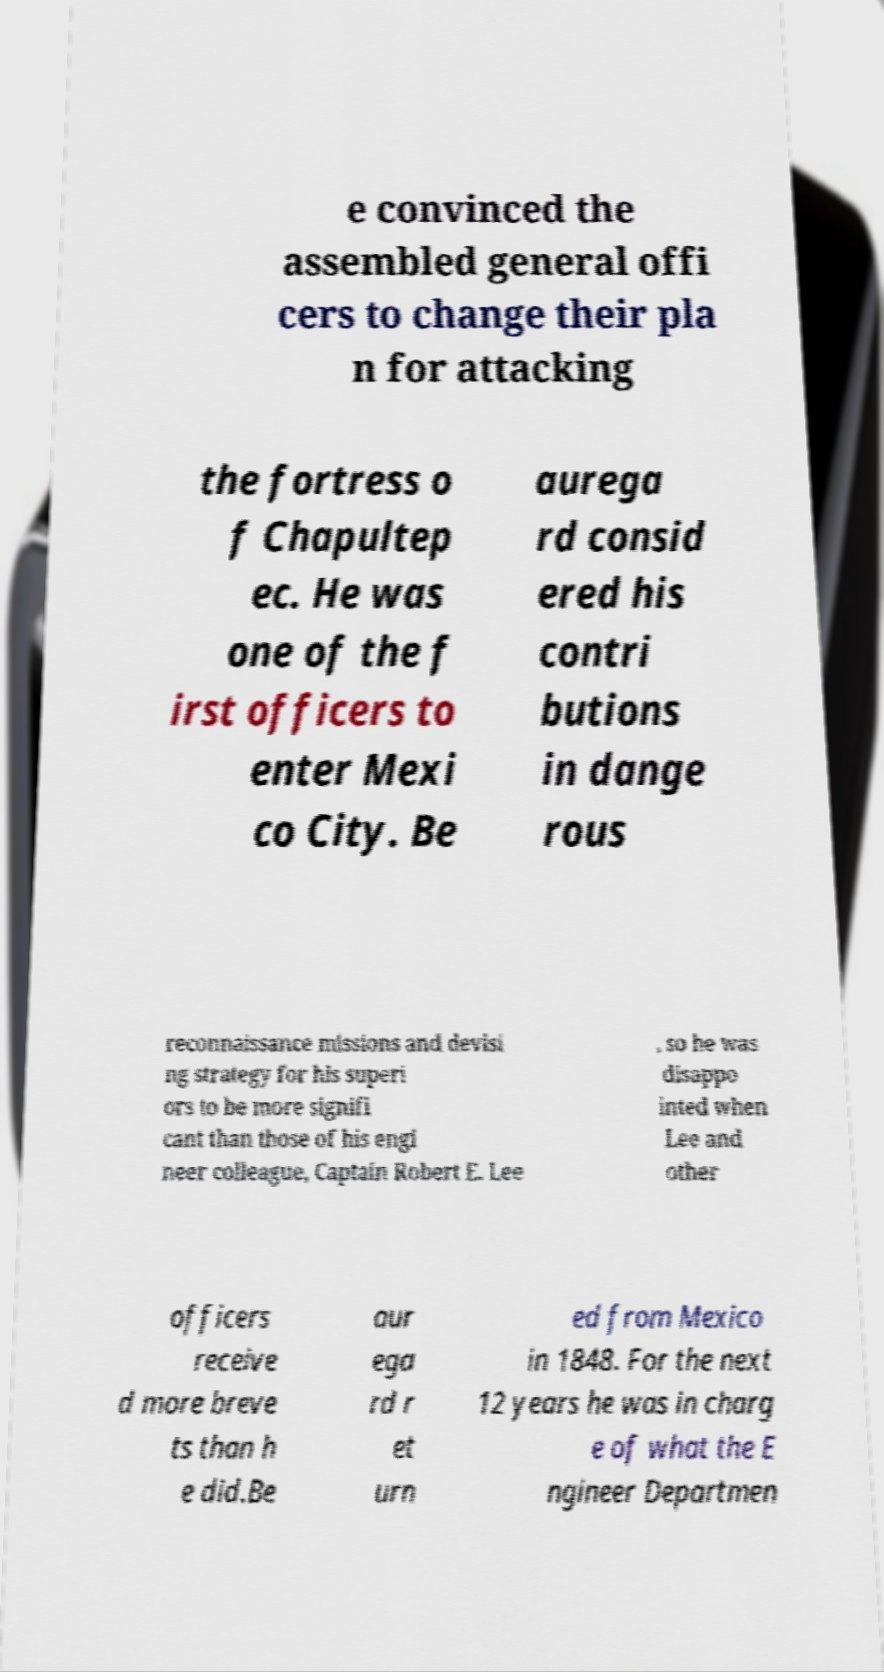What messages or text are displayed in this image? I need them in a readable, typed format. e convinced the assembled general offi cers to change their pla n for attacking the fortress o f Chapultep ec. He was one of the f irst officers to enter Mexi co City. Be aurega rd consid ered his contri butions in dange rous reconnaissance missions and devisi ng strategy for his superi ors to be more signifi cant than those of his engi neer colleague, Captain Robert E. Lee , so he was disappo inted when Lee and other officers receive d more breve ts than h e did.Be aur ega rd r et urn ed from Mexico in 1848. For the next 12 years he was in charg e of what the E ngineer Departmen 